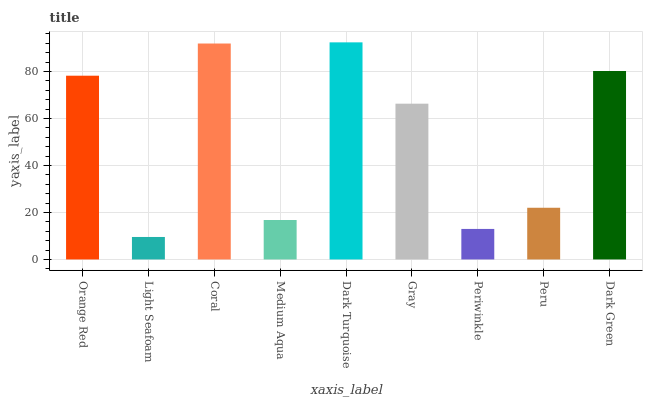Is Light Seafoam the minimum?
Answer yes or no. Yes. Is Dark Turquoise the maximum?
Answer yes or no. Yes. Is Coral the minimum?
Answer yes or no. No. Is Coral the maximum?
Answer yes or no. No. Is Coral greater than Light Seafoam?
Answer yes or no. Yes. Is Light Seafoam less than Coral?
Answer yes or no. Yes. Is Light Seafoam greater than Coral?
Answer yes or no. No. Is Coral less than Light Seafoam?
Answer yes or no. No. Is Gray the high median?
Answer yes or no. Yes. Is Gray the low median?
Answer yes or no. Yes. Is Dark Turquoise the high median?
Answer yes or no. No. Is Dark Turquoise the low median?
Answer yes or no. No. 